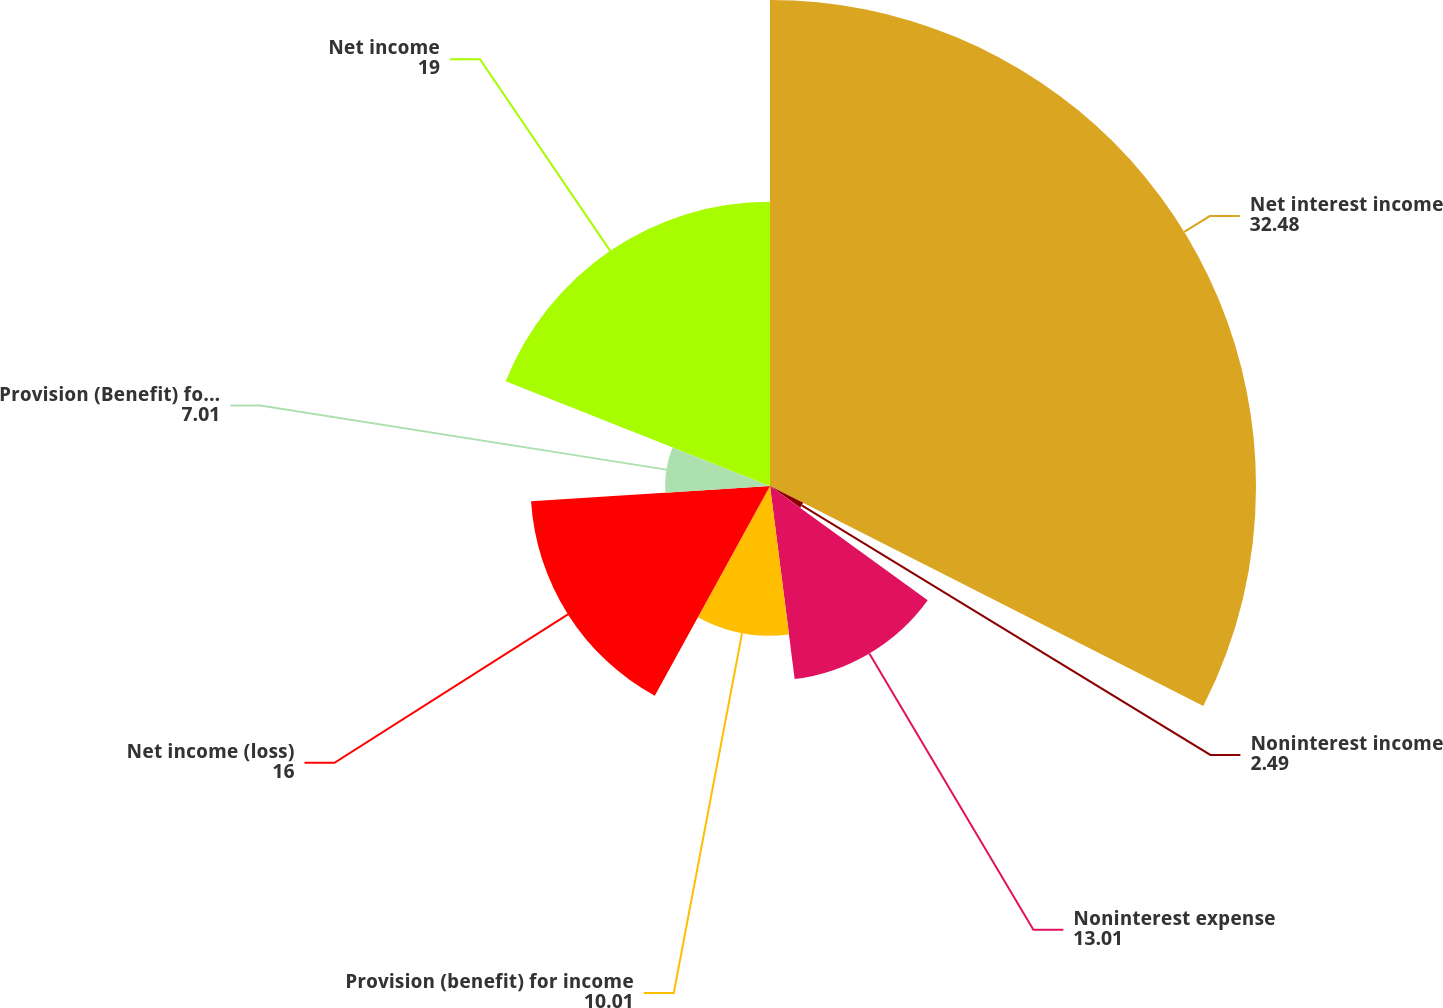Convert chart to OTSL. <chart><loc_0><loc_0><loc_500><loc_500><pie_chart><fcel>Net interest income<fcel>Noninterest income<fcel>Noninterest expense<fcel>Provision (benefit) for income<fcel>Net income (loss)<fcel>Provision (Benefit) for credit<fcel>Net income<nl><fcel>32.48%<fcel>2.49%<fcel>13.01%<fcel>10.01%<fcel>16.0%<fcel>7.01%<fcel>19.0%<nl></chart> 